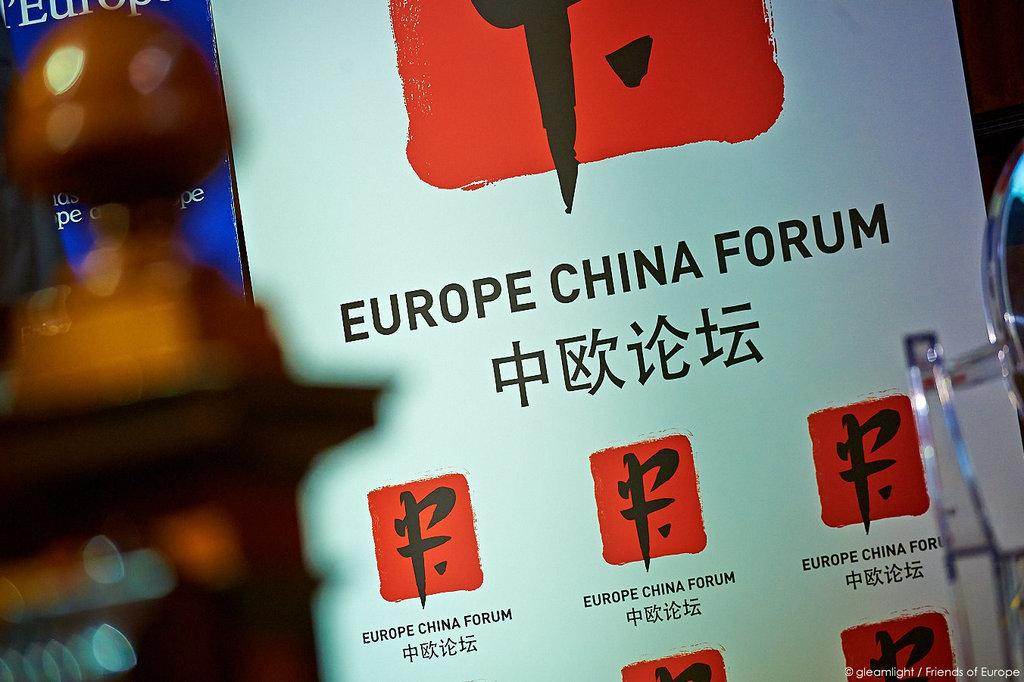<image>
Write a terse but informative summary of the picture. An English/Chinese language sign board containing the logo for the Europe China Forum. 